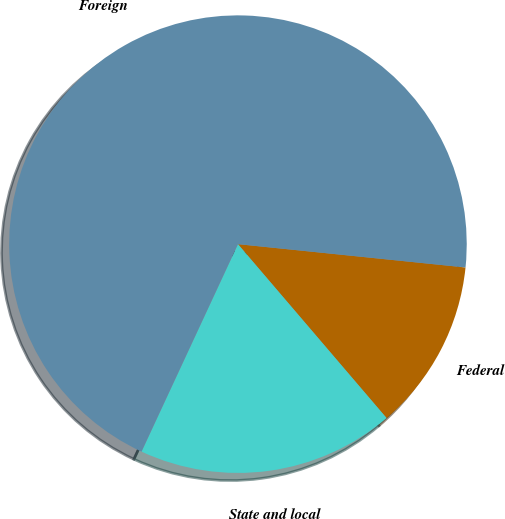<chart> <loc_0><loc_0><loc_500><loc_500><pie_chart><fcel>Federal<fcel>State and local<fcel>Foreign<nl><fcel>12.12%<fcel>18.18%<fcel>69.7%<nl></chart> 